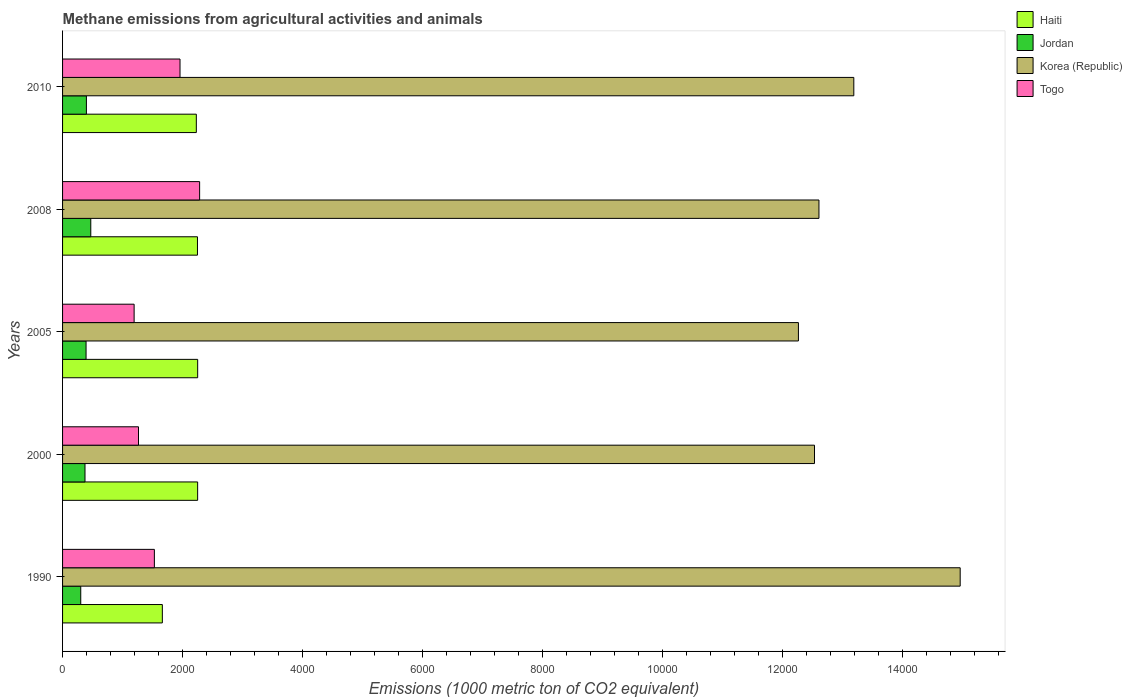How many different coloured bars are there?
Offer a very short reply. 4. Are the number of bars on each tick of the Y-axis equal?
Provide a succinct answer. Yes. How many bars are there on the 1st tick from the bottom?
Your answer should be very brief. 4. In how many cases, is the number of bars for a given year not equal to the number of legend labels?
Provide a short and direct response. 0. What is the amount of methane emitted in Jordan in 1990?
Your response must be concise. 303.3. Across all years, what is the maximum amount of methane emitted in Togo?
Your answer should be compact. 2285.6. Across all years, what is the minimum amount of methane emitted in Jordan?
Your answer should be very brief. 303.3. What is the total amount of methane emitted in Jordan in the graph?
Keep it short and to the point. 1937.1. What is the difference between the amount of methane emitted in Haiti in 1990 and that in 2008?
Your answer should be very brief. -585.6. What is the difference between the amount of methane emitted in Togo in 1990 and the amount of methane emitted in Haiti in 2005?
Offer a very short reply. -721.9. What is the average amount of methane emitted in Haiti per year?
Make the answer very short. 2129.88. In the year 1990, what is the difference between the amount of methane emitted in Togo and amount of methane emitted in Jordan?
Offer a very short reply. 1227.8. What is the ratio of the amount of methane emitted in Togo in 2000 to that in 2008?
Offer a very short reply. 0.55. Is the amount of methane emitted in Togo in 2000 less than that in 2008?
Offer a terse response. Yes. Is the difference between the amount of methane emitted in Togo in 1990 and 2000 greater than the difference between the amount of methane emitted in Jordan in 1990 and 2000?
Your answer should be compact. Yes. What is the difference between the highest and the second highest amount of methane emitted in Korea (Republic)?
Ensure brevity in your answer.  1774. What is the difference between the highest and the lowest amount of methane emitted in Korea (Republic)?
Provide a short and direct response. 2697.7. Is it the case that in every year, the sum of the amount of methane emitted in Korea (Republic) and amount of methane emitted in Haiti is greater than the sum of amount of methane emitted in Togo and amount of methane emitted in Jordan?
Offer a terse response. Yes. What does the 3rd bar from the top in 2010 represents?
Your answer should be compact. Jordan. What does the 3rd bar from the bottom in 2008 represents?
Give a very brief answer. Korea (Republic). Is it the case that in every year, the sum of the amount of methane emitted in Korea (Republic) and amount of methane emitted in Togo is greater than the amount of methane emitted in Jordan?
Give a very brief answer. Yes. How many bars are there?
Give a very brief answer. 20. What is the difference between two consecutive major ticks on the X-axis?
Keep it short and to the point. 2000. Are the values on the major ticks of X-axis written in scientific E-notation?
Ensure brevity in your answer.  No. Does the graph contain grids?
Offer a terse response. No. Where does the legend appear in the graph?
Provide a short and direct response. Top right. How many legend labels are there?
Offer a very short reply. 4. How are the legend labels stacked?
Offer a very short reply. Vertical. What is the title of the graph?
Your answer should be very brief. Methane emissions from agricultural activities and animals. What is the label or title of the X-axis?
Offer a very short reply. Emissions (1000 metric ton of CO2 equivalent). What is the Emissions (1000 metric ton of CO2 equivalent) in Haiti in 1990?
Keep it short and to the point. 1663.9. What is the Emissions (1000 metric ton of CO2 equivalent) in Jordan in 1990?
Provide a short and direct response. 303.3. What is the Emissions (1000 metric ton of CO2 equivalent) in Korea (Republic) in 1990?
Ensure brevity in your answer.  1.50e+04. What is the Emissions (1000 metric ton of CO2 equivalent) of Togo in 1990?
Your answer should be very brief. 1531.1. What is the Emissions (1000 metric ton of CO2 equivalent) of Haiti in 2000?
Offer a very short reply. 2252.5. What is the Emissions (1000 metric ton of CO2 equivalent) of Jordan in 2000?
Provide a short and direct response. 374. What is the Emissions (1000 metric ton of CO2 equivalent) in Korea (Republic) in 2000?
Keep it short and to the point. 1.25e+04. What is the Emissions (1000 metric ton of CO2 equivalent) in Togo in 2000?
Keep it short and to the point. 1266.2. What is the Emissions (1000 metric ton of CO2 equivalent) of Haiti in 2005?
Keep it short and to the point. 2253. What is the Emissions (1000 metric ton of CO2 equivalent) in Jordan in 2005?
Give a very brief answer. 391.8. What is the Emissions (1000 metric ton of CO2 equivalent) of Korea (Republic) in 2005?
Keep it short and to the point. 1.23e+04. What is the Emissions (1000 metric ton of CO2 equivalent) in Togo in 2005?
Give a very brief answer. 1193.3. What is the Emissions (1000 metric ton of CO2 equivalent) of Haiti in 2008?
Your response must be concise. 2249.5. What is the Emissions (1000 metric ton of CO2 equivalent) in Jordan in 2008?
Offer a terse response. 470.4. What is the Emissions (1000 metric ton of CO2 equivalent) in Korea (Republic) in 2008?
Keep it short and to the point. 1.26e+04. What is the Emissions (1000 metric ton of CO2 equivalent) of Togo in 2008?
Offer a terse response. 2285.6. What is the Emissions (1000 metric ton of CO2 equivalent) of Haiti in 2010?
Your answer should be very brief. 2230.5. What is the Emissions (1000 metric ton of CO2 equivalent) of Jordan in 2010?
Ensure brevity in your answer.  397.6. What is the Emissions (1000 metric ton of CO2 equivalent) of Korea (Republic) in 2010?
Your response must be concise. 1.32e+04. What is the Emissions (1000 metric ton of CO2 equivalent) in Togo in 2010?
Ensure brevity in your answer.  1958.5. Across all years, what is the maximum Emissions (1000 metric ton of CO2 equivalent) of Haiti?
Your answer should be very brief. 2253. Across all years, what is the maximum Emissions (1000 metric ton of CO2 equivalent) in Jordan?
Provide a succinct answer. 470.4. Across all years, what is the maximum Emissions (1000 metric ton of CO2 equivalent) in Korea (Republic)?
Offer a very short reply. 1.50e+04. Across all years, what is the maximum Emissions (1000 metric ton of CO2 equivalent) of Togo?
Give a very brief answer. 2285.6. Across all years, what is the minimum Emissions (1000 metric ton of CO2 equivalent) in Haiti?
Your answer should be very brief. 1663.9. Across all years, what is the minimum Emissions (1000 metric ton of CO2 equivalent) of Jordan?
Your answer should be very brief. 303.3. Across all years, what is the minimum Emissions (1000 metric ton of CO2 equivalent) in Korea (Republic)?
Make the answer very short. 1.23e+04. Across all years, what is the minimum Emissions (1000 metric ton of CO2 equivalent) in Togo?
Offer a terse response. 1193.3. What is the total Emissions (1000 metric ton of CO2 equivalent) of Haiti in the graph?
Offer a very short reply. 1.06e+04. What is the total Emissions (1000 metric ton of CO2 equivalent) of Jordan in the graph?
Your answer should be very brief. 1937.1. What is the total Emissions (1000 metric ton of CO2 equivalent) of Korea (Republic) in the graph?
Offer a very short reply. 6.56e+04. What is the total Emissions (1000 metric ton of CO2 equivalent) in Togo in the graph?
Your answer should be compact. 8234.7. What is the difference between the Emissions (1000 metric ton of CO2 equivalent) in Haiti in 1990 and that in 2000?
Keep it short and to the point. -588.6. What is the difference between the Emissions (1000 metric ton of CO2 equivalent) of Jordan in 1990 and that in 2000?
Your answer should be very brief. -70.7. What is the difference between the Emissions (1000 metric ton of CO2 equivalent) in Korea (Republic) in 1990 and that in 2000?
Keep it short and to the point. 2429.6. What is the difference between the Emissions (1000 metric ton of CO2 equivalent) of Togo in 1990 and that in 2000?
Offer a terse response. 264.9. What is the difference between the Emissions (1000 metric ton of CO2 equivalent) of Haiti in 1990 and that in 2005?
Provide a succinct answer. -589.1. What is the difference between the Emissions (1000 metric ton of CO2 equivalent) of Jordan in 1990 and that in 2005?
Ensure brevity in your answer.  -88.5. What is the difference between the Emissions (1000 metric ton of CO2 equivalent) in Korea (Republic) in 1990 and that in 2005?
Keep it short and to the point. 2697.7. What is the difference between the Emissions (1000 metric ton of CO2 equivalent) in Togo in 1990 and that in 2005?
Make the answer very short. 337.8. What is the difference between the Emissions (1000 metric ton of CO2 equivalent) in Haiti in 1990 and that in 2008?
Your answer should be compact. -585.6. What is the difference between the Emissions (1000 metric ton of CO2 equivalent) of Jordan in 1990 and that in 2008?
Your response must be concise. -167.1. What is the difference between the Emissions (1000 metric ton of CO2 equivalent) in Korea (Republic) in 1990 and that in 2008?
Make the answer very short. 2355.3. What is the difference between the Emissions (1000 metric ton of CO2 equivalent) of Togo in 1990 and that in 2008?
Provide a short and direct response. -754.5. What is the difference between the Emissions (1000 metric ton of CO2 equivalent) of Haiti in 1990 and that in 2010?
Offer a terse response. -566.6. What is the difference between the Emissions (1000 metric ton of CO2 equivalent) in Jordan in 1990 and that in 2010?
Make the answer very short. -94.3. What is the difference between the Emissions (1000 metric ton of CO2 equivalent) in Korea (Republic) in 1990 and that in 2010?
Your answer should be very brief. 1774. What is the difference between the Emissions (1000 metric ton of CO2 equivalent) in Togo in 1990 and that in 2010?
Your answer should be very brief. -427.4. What is the difference between the Emissions (1000 metric ton of CO2 equivalent) in Jordan in 2000 and that in 2005?
Your response must be concise. -17.8. What is the difference between the Emissions (1000 metric ton of CO2 equivalent) of Korea (Republic) in 2000 and that in 2005?
Your answer should be compact. 268.1. What is the difference between the Emissions (1000 metric ton of CO2 equivalent) in Togo in 2000 and that in 2005?
Keep it short and to the point. 72.9. What is the difference between the Emissions (1000 metric ton of CO2 equivalent) in Haiti in 2000 and that in 2008?
Keep it short and to the point. 3. What is the difference between the Emissions (1000 metric ton of CO2 equivalent) in Jordan in 2000 and that in 2008?
Offer a terse response. -96.4. What is the difference between the Emissions (1000 metric ton of CO2 equivalent) of Korea (Republic) in 2000 and that in 2008?
Offer a very short reply. -74.3. What is the difference between the Emissions (1000 metric ton of CO2 equivalent) in Togo in 2000 and that in 2008?
Give a very brief answer. -1019.4. What is the difference between the Emissions (1000 metric ton of CO2 equivalent) of Haiti in 2000 and that in 2010?
Your answer should be compact. 22. What is the difference between the Emissions (1000 metric ton of CO2 equivalent) in Jordan in 2000 and that in 2010?
Your answer should be compact. -23.6. What is the difference between the Emissions (1000 metric ton of CO2 equivalent) in Korea (Republic) in 2000 and that in 2010?
Offer a very short reply. -655.6. What is the difference between the Emissions (1000 metric ton of CO2 equivalent) of Togo in 2000 and that in 2010?
Your answer should be very brief. -692.3. What is the difference between the Emissions (1000 metric ton of CO2 equivalent) of Jordan in 2005 and that in 2008?
Keep it short and to the point. -78.6. What is the difference between the Emissions (1000 metric ton of CO2 equivalent) in Korea (Republic) in 2005 and that in 2008?
Offer a terse response. -342.4. What is the difference between the Emissions (1000 metric ton of CO2 equivalent) in Togo in 2005 and that in 2008?
Provide a short and direct response. -1092.3. What is the difference between the Emissions (1000 metric ton of CO2 equivalent) of Haiti in 2005 and that in 2010?
Your response must be concise. 22.5. What is the difference between the Emissions (1000 metric ton of CO2 equivalent) of Jordan in 2005 and that in 2010?
Your answer should be compact. -5.8. What is the difference between the Emissions (1000 metric ton of CO2 equivalent) of Korea (Republic) in 2005 and that in 2010?
Your response must be concise. -923.7. What is the difference between the Emissions (1000 metric ton of CO2 equivalent) of Togo in 2005 and that in 2010?
Offer a very short reply. -765.2. What is the difference between the Emissions (1000 metric ton of CO2 equivalent) of Jordan in 2008 and that in 2010?
Provide a succinct answer. 72.8. What is the difference between the Emissions (1000 metric ton of CO2 equivalent) in Korea (Republic) in 2008 and that in 2010?
Offer a terse response. -581.3. What is the difference between the Emissions (1000 metric ton of CO2 equivalent) in Togo in 2008 and that in 2010?
Your answer should be compact. 327.1. What is the difference between the Emissions (1000 metric ton of CO2 equivalent) in Haiti in 1990 and the Emissions (1000 metric ton of CO2 equivalent) in Jordan in 2000?
Your answer should be very brief. 1289.9. What is the difference between the Emissions (1000 metric ton of CO2 equivalent) of Haiti in 1990 and the Emissions (1000 metric ton of CO2 equivalent) of Korea (Republic) in 2000?
Offer a terse response. -1.09e+04. What is the difference between the Emissions (1000 metric ton of CO2 equivalent) in Haiti in 1990 and the Emissions (1000 metric ton of CO2 equivalent) in Togo in 2000?
Ensure brevity in your answer.  397.7. What is the difference between the Emissions (1000 metric ton of CO2 equivalent) in Jordan in 1990 and the Emissions (1000 metric ton of CO2 equivalent) in Korea (Republic) in 2000?
Your answer should be very brief. -1.22e+04. What is the difference between the Emissions (1000 metric ton of CO2 equivalent) of Jordan in 1990 and the Emissions (1000 metric ton of CO2 equivalent) of Togo in 2000?
Make the answer very short. -962.9. What is the difference between the Emissions (1000 metric ton of CO2 equivalent) in Korea (Republic) in 1990 and the Emissions (1000 metric ton of CO2 equivalent) in Togo in 2000?
Your answer should be very brief. 1.37e+04. What is the difference between the Emissions (1000 metric ton of CO2 equivalent) in Haiti in 1990 and the Emissions (1000 metric ton of CO2 equivalent) in Jordan in 2005?
Provide a short and direct response. 1272.1. What is the difference between the Emissions (1000 metric ton of CO2 equivalent) in Haiti in 1990 and the Emissions (1000 metric ton of CO2 equivalent) in Korea (Republic) in 2005?
Your response must be concise. -1.06e+04. What is the difference between the Emissions (1000 metric ton of CO2 equivalent) in Haiti in 1990 and the Emissions (1000 metric ton of CO2 equivalent) in Togo in 2005?
Provide a short and direct response. 470.6. What is the difference between the Emissions (1000 metric ton of CO2 equivalent) of Jordan in 1990 and the Emissions (1000 metric ton of CO2 equivalent) of Korea (Republic) in 2005?
Offer a terse response. -1.20e+04. What is the difference between the Emissions (1000 metric ton of CO2 equivalent) of Jordan in 1990 and the Emissions (1000 metric ton of CO2 equivalent) of Togo in 2005?
Provide a succinct answer. -890. What is the difference between the Emissions (1000 metric ton of CO2 equivalent) in Korea (Republic) in 1990 and the Emissions (1000 metric ton of CO2 equivalent) in Togo in 2005?
Your answer should be very brief. 1.38e+04. What is the difference between the Emissions (1000 metric ton of CO2 equivalent) in Haiti in 1990 and the Emissions (1000 metric ton of CO2 equivalent) in Jordan in 2008?
Your answer should be compact. 1193.5. What is the difference between the Emissions (1000 metric ton of CO2 equivalent) of Haiti in 1990 and the Emissions (1000 metric ton of CO2 equivalent) of Korea (Republic) in 2008?
Offer a very short reply. -1.09e+04. What is the difference between the Emissions (1000 metric ton of CO2 equivalent) in Haiti in 1990 and the Emissions (1000 metric ton of CO2 equivalent) in Togo in 2008?
Your answer should be very brief. -621.7. What is the difference between the Emissions (1000 metric ton of CO2 equivalent) of Jordan in 1990 and the Emissions (1000 metric ton of CO2 equivalent) of Korea (Republic) in 2008?
Provide a short and direct response. -1.23e+04. What is the difference between the Emissions (1000 metric ton of CO2 equivalent) of Jordan in 1990 and the Emissions (1000 metric ton of CO2 equivalent) of Togo in 2008?
Offer a terse response. -1982.3. What is the difference between the Emissions (1000 metric ton of CO2 equivalent) of Korea (Republic) in 1990 and the Emissions (1000 metric ton of CO2 equivalent) of Togo in 2008?
Ensure brevity in your answer.  1.27e+04. What is the difference between the Emissions (1000 metric ton of CO2 equivalent) of Haiti in 1990 and the Emissions (1000 metric ton of CO2 equivalent) of Jordan in 2010?
Offer a very short reply. 1266.3. What is the difference between the Emissions (1000 metric ton of CO2 equivalent) of Haiti in 1990 and the Emissions (1000 metric ton of CO2 equivalent) of Korea (Republic) in 2010?
Offer a terse response. -1.15e+04. What is the difference between the Emissions (1000 metric ton of CO2 equivalent) of Haiti in 1990 and the Emissions (1000 metric ton of CO2 equivalent) of Togo in 2010?
Your answer should be compact. -294.6. What is the difference between the Emissions (1000 metric ton of CO2 equivalent) in Jordan in 1990 and the Emissions (1000 metric ton of CO2 equivalent) in Korea (Republic) in 2010?
Your response must be concise. -1.29e+04. What is the difference between the Emissions (1000 metric ton of CO2 equivalent) of Jordan in 1990 and the Emissions (1000 metric ton of CO2 equivalent) of Togo in 2010?
Ensure brevity in your answer.  -1655.2. What is the difference between the Emissions (1000 metric ton of CO2 equivalent) of Korea (Republic) in 1990 and the Emissions (1000 metric ton of CO2 equivalent) of Togo in 2010?
Offer a very short reply. 1.30e+04. What is the difference between the Emissions (1000 metric ton of CO2 equivalent) of Haiti in 2000 and the Emissions (1000 metric ton of CO2 equivalent) of Jordan in 2005?
Make the answer very short. 1860.7. What is the difference between the Emissions (1000 metric ton of CO2 equivalent) of Haiti in 2000 and the Emissions (1000 metric ton of CO2 equivalent) of Korea (Republic) in 2005?
Give a very brief answer. -1.00e+04. What is the difference between the Emissions (1000 metric ton of CO2 equivalent) in Haiti in 2000 and the Emissions (1000 metric ton of CO2 equivalent) in Togo in 2005?
Provide a short and direct response. 1059.2. What is the difference between the Emissions (1000 metric ton of CO2 equivalent) of Jordan in 2000 and the Emissions (1000 metric ton of CO2 equivalent) of Korea (Republic) in 2005?
Your answer should be compact. -1.19e+04. What is the difference between the Emissions (1000 metric ton of CO2 equivalent) in Jordan in 2000 and the Emissions (1000 metric ton of CO2 equivalent) in Togo in 2005?
Provide a succinct answer. -819.3. What is the difference between the Emissions (1000 metric ton of CO2 equivalent) of Korea (Republic) in 2000 and the Emissions (1000 metric ton of CO2 equivalent) of Togo in 2005?
Your answer should be compact. 1.13e+04. What is the difference between the Emissions (1000 metric ton of CO2 equivalent) in Haiti in 2000 and the Emissions (1000 metric ton of CO2 equivalent) in Jordan in 2008?
Give a very brief answer. 1782.1. What is the difference between the Emissions (1000 metric ton of CO2 equivalent) in Haiti in 2000 and the Emissions (1000 metric ton of CO2 equivalent) in Korea (Republic) in 2008?
Give a very brief answer. -1.04e+04. What is the difference between the Emissions (1000 metric ton of CO2 equivalent) in Haiti in 2000 and the Emissions (1000 metric ton of CO2 equivalent) in Togo in 2008?
Keep it short and to the point. -33.1. What is the difference between the Emissions (1000 metric ton of CO2 equivalent) in Jordan in 2000 and the Emissions (1000 metric ton of CO2 equivalent) in Korea (Republic) in 2008?
Keep it short and to the point. -1.22e+04. What is the difference between the Emissions (1000 metric ton of CO2 equivalent) of Jordan in 2000 and the Emissions (1000 metric ton of CO2 equivalent) of Togo in 2008?
Keep it short and to the point. -1911.6. What is the difference between the Emissions (1000 metric ton of CO2 equivalent) of Korea (Republic) in 2000 and the Emissions (1000 metric ton of CO2 equivalent) of Togo in 2008?
Give a very brief answer. 1.03e+04. What is the difference between the Emissions (1000 metric ton of CO2 equivalent) in Haiti in 2000 and the Emissions (1000 metric ton of CO2 equivalent) in Jordan in 2010?
Make the answer very short. 1854.9. What is the difference between the Emissions (1000 metric ton of CO2 equivalent) of Haiti in 2000 and the Emissions (1000 metric ton of CO2 equivalent) of Korea (Republic) in 2010?
Your response must be concise. -1.09e+04. What is the difference between the Emissions (1000 metric ton of CO2 equivalent) of Haiti in 2000 and the Emissions (1000 metric ton of CO2 equivalent) of Togo in 2010?
Make the answer very short. 294. What is the difference between the Emissions (1000 metric ton of CO2 equivalent) of Jordan in 2000 and the Emissions (1000 metric ton of CO2 equivalent) of Korea (Republic) in 2010?
Make the answer very short. -1.28e+04. What is the difference between the Emissions (1000 metric ton of CO2 equivalent) of Jordan in 2000 and the Emissions (1000 metric ton of CO2 equivalent) of Togo in 2010?
Ensure brevity in your answer.  -1584.5. What is the difference between the Emissions (1000 metric ton of CO2 equivalent) in Korea (Republic) in 2000 and the Emissions (1000 metric ton of CO2 equivalent) in Togo in 2010?
Ensure brevity in your answer.  1.06e+04. What is the difference between the Emissions (1000 metric ton of CO2 equivalent) of Haiti in 2005 and the Emissions (1000 metric ton of CO2 equivalent) of Jordan in 2008?
Provide a short and direct response. 1782.6. What is the difference between the Emissions (1000 metric ton of CO2 equivalent) of Haiti in 2005 and the Emissions (1000 metric ton of CO2 equivalent) of Korea (Republic) in 2008?
Your answer should be very brief. -1.04e+04. What is the difference between the Emissions (1000 metric ton of CO2 equivalent) in Haiti in 2005 and the Emissions (1000 metric ton of CO2 equivalent) in Togo in 2008?
Offer a very short reply. -32.6. What is the difference between the Emissions (1000 metric ton of CO2 equivalent) of Jordan in 2005 and the Emissions (1000 metric ton of CO2 equivalent) of Korea (Republic) in 2008?
Provide a short and direct response. -1.22e+04. What is the difference between the Emissions (1000 metric ton of CO2 equivalent) in Jordan in 2005 and the Emissions (1000 metric ton of CO2 equivalent) in Togo in 2008?
Your answer should be compact. -1893.8. What is the difference between the Emissions (1000 metric ton of CO2 equivalent) in Korea (Republic) in 2005 and the Emissions (1000 metric ton of CO2 equivalent) in Togo in 2008?
Make the answer very short. 9985.4. What is the difference between the Emissions (1000 metric ton of CO2 equivalent) of Haiti in 2005 and the Emissions (1000 metric ton of CO2 equivalent) of Jordan in 2010?
Keep it short and to the point. 1855.4. What is the difference between the Emissions (1000 metric ton of CO2 equivalent) in Haiti in 2005 and the Emissions (1000 metric ton of CO2 equivalent) in Korea (Republic) in 2010?
Keep it short and to the point. -1.09e+04. What is the difference between the Emissions (1000 metric ton of CO2 equivalent) of Haiti in 2005 and the Emissions (1000 metric ton of CO2 equivalent) of Togo in 2010?
Make the answer very short. 294.5. What is the difference between the Emissions (1000 metric ton of CO2 equivalent) of Jordan in 2005 and the Emissions (1000 metric ton of CO2 equivalent) of Korea (Republic) in 2010?
Offer a terse response. -1.28e+04. What is the difference between the Emissions (1000 metric ton of CO2 equivalent) of Jordan in 2005 and the Emissions (1000 metric ton of CO2 equivalent) of Togo in 2010?
Make the answer very short. -1566.7. What is the difference between the Emissions (1000 metric ton of CO2 equivalent) in Korea (Republic) in 2005 and the Emissions (1000 metric ton of CO2 equivalent) in Togo in 2010?
Ensure brevity in your answer.  1.03e+04. What is the difference between the Emissions (1000 metric ton of CO2 equivalent) of Haiti in 2008 and the Emissions (1000 metric ton of CO2 equivalent) of Jordan in 2010?
Keep it short and to the point. 1851.9. What is the difference between the Emissions (1000 metric ton of CO2 equivalent) in Haiti in 2008 and the Emissions (1000 metric ton of CO2 equivalent) in Korea (Republic) in 2010?
Your response must be concise. -1.09e+04. What is the difference between the Emissions (1000 metric ton of CO2 equivalent) in Haiti in 2008 and the Emissions (1000 metric ton of CO2 equivalent) in Togo in 2010?
Offer a terse response. 291. What is the difference between the Emissions (1000 metric ton of CO2 equivalent) of Jordan in 2008 and the Emissions (1000 metric ton of CO2 equivalent) of Korea (Republic) in 2010?
Your response must be concise. -1.27e+04. What is the difference between the Emissions (1000 metric ton of CO2 equivalent) in Jordan in 2008 and the Emissions (1000 metric ton of CO2 equivalent) in Togo in 2010?
Keep it short and to the point. -1488.1. What is the difference between the Emissions (1000 metric ton of CO2 equivalent) of Korea (Republic) in 2008 and the Emissions (1000 metric ton of CO2 equivalent) of Togo in 2010?
Make the answer very short. 1.07e+04. What is the average Emissions (1000 metric ton of CO2 equivalent) of Haiti per year?
Provide a short and direct response. 2129.88. What is the average Emissions (1000 metric ton of CO2 equivalent) of Jordan per year?
Provide a succinct answer. 387.42. What is the average Emissions (1000 metric ton of CO2 equivalent) in Korea (Republic) per year?
Make the answer very short. 1.31e+04. What is the average Emissions (1000 metric ton of CO2 equivalent) in Togo per year?
Keep it short and to the point. 1646.94. In the year 1990, what is the difference between the Emissions (1000 metric ton of CO2 equivalent) in Haiti and Emissions (1000 metric ton of CO2 equivalent) in Jordan?
Keep it short and to the point. 1360.6. In the year 1990, what is the difference between the Emissions (1000 metric ton of CO2 equivalent) of Haiti and Emissions (1000 metric ton of CO2 equivalent) of Korea (Republic)?
Offer a very short reply. -1.33e+04. In the year 1990, what is the difference between the Emissions (1000 metric ton of CO2 equivalent) in Haiti and Emissions (1000 metric ton of CO2 equivalent) in Togo?
Provide a succinct answer. 132.8. In the year 1990, what is the difference between the Emissions (1000 metric ton of CO2 equivalent) in Jordan and Emissions (1000 metric ton of CO2 equivalent) in Korea (Republic)?
Offer a very short reply. -1.47e+04. In the year 1990, what is the difference between the Emissions (1000 metric ton of CO2 equivalent) in Jordan and Emissions (1000 metric ton of CO2 equivalent) in Togo?
Provide a succinct answer. -1227.8. In the year 1990, what is the difference between the Emissions (1000 metric ton of CO2 equivalent) of Korea (Republic) and Emissions (1000 metric ton of CO2 equivalent) of Togo?
Provide a short and direct response. 1.34e+04. In the year 2000, what is the difference between the Emissions (1000 metric ton of CO2 equivalent) in Haiti and Emissions (1000 metric ton of CO2 equivalent) in Jordan?
Ensure brevity in your answer.  1878.5. In the year 2000, what is the difference between the Emissions (1000 metric ton of CO2 equivalent) in Haiti and Emissions (1000 metric ton of CO2 equivalent) in Korea (Republic)?
Give a very brief answer. -1.03e+04. In the year 2000, what is the difference between the Emissions (1000 metric ton of CO2 equivalent) of Haiti and Emissions (1000 metric ton of CO2 equivalent) of Togo?
Ensure brevity in your answer.  986.3. In the year 2000, what is the difference between the Emissions (1000 metric ton of CO2 equivalent) in Jordan and Emissions (1000 metric ton of CO2 equivalent) in Korea (Republic)?
Your answer should be very brief. -1.22e+04. In the year 2000, what is the difference between the Emissions (1000 metric ton of CO2 equivalent) in Jordan and Emissions (1000 metric ton of CO2 equivalent) in Togo?
Your answer should be compact. -892.2. In the year 2000, what is the difference between the Emissions (1000 metric ton of CO2 equivalent) in Korea (Republic) and Emissions (1000 metric ton of CO2 equivalent) in Togo?
Offer a very short reply. 1.13e+04. In the year 2005, what is the difference between the Emissions (1000 metric ton of CO2 equivalent) of Haiti and Emissions (1000 metric ton of CO2 equivalent) of Jordan?
Your response must be concise. 1861.2. In the year 2005, what is the difference between the Emissions (1000 metric ton of CO2 equivalent) of Haiti and Emissions (1000 metric ton of CO2 equivalent) of Korea (Republic)?
Give a very brief answer. -1.00e+04. In the year 2005, what is the difference between the Emissions (1000 metric ton of CO2 equivalent) in Haiti and Emissions (1000 metric ton of CO2 equivalent) in Togo?
Keep it short and to the point. 1059.7. In the year 2005, what is the difference between the Emissions (1000 metric ton of CO2 equivalent) of Jordan and Emissions (1000 metric ton of CO2 equivalent) of Korea (Republic)?
Offer a very short reply. -1.19e+04. In the year 2005, what is the difference between the Emissions (1000 metric ton of CO2 equivalent) in Jordan and Emissions (1000 metric ton of CO2 equivalent) in Togo?
Provide a succinct answer. -801.5. In the year 2005, what is the difference between the Emissions (1000 metric ton of CO2 equivalent) in Korea (Republic) and Emissions (1000 metric ton of CO2 equivalent) in Togo?
Give a very brief answer. 1.11e+04. In the year 2008, what is the difference between the Emissions (1000 metric ton of CO2 equivalent) of Haiti and Emissions (1000 metric ton of CO2 equivalent) of Jordan?
Your answer should be very brief. 1779.1. In the year 2008, what is the difference between the Emissions (1000 metric ton of CO2 equivalent) of Haiti and Emissions (1000 metric ton of CO2 equivalent) of Korea (Republic)?
Ensure brevity in your answer.  -1.04e+04. In the year 2008, what is the difference between the Emissions (1000 metric ton of CO2 equivalent) of Haiti and Emissions (1000 metric ton of CO2 equivalent) of Togo?
Make the answer very short. -36.1. In the year 2008, what is the difference between the Emissions (1000 metric ton of CO2 equivalent) of Jordan and Emissions (1000 metric ton of CO2 equivalent) of Korea (Republic)?
Keep it short and to the point. -1.21e+04. In the year 2008, what is the difference between the Emissions (1000 metric ton of CO2 equivalent) in Jordan and Emissions (1000 metric ton of CO2 equivalent) in Togo?
Your answer should be very brief. -1815.2. In the year 2008, what is the difference between the Emissions (1000 metric ton of CO2 equivalent) in Korea (Republic) and Emissions (1000 metric ton of CO2 equivalent) in Togo?
Offer a very short reply. 1.03e+04. In the year 2010, what is the difference between the Emissions (1000 metric ton of CO2 equivalent) in Haiti and Emissions (1000 metric ton of CO2 equivalent) in Jordan?
Provide a succinct answer. 1832.9. In the year 2010, what is the difference between the Emissions (1000 metric ton of CO2 equivalent) of Haiti and Emissions (1000 metric ton of CO2 equivalent) of Korea (Republic)?
Your answer should be compact. -1.10e+04. In the year 2010, what is the difference between the Emissions (1000 metric ton of CO2 equivalent) of Haiti and Emissions (1000 metric ton of CO2 equivalent) of Togo?
Make the answer very short. 272. In the year 2010, what is the difference between the Emissions (1000 metric ton of CO2 equivalent) of Jordan and Emissions (1000 metric ton of CO2 equivalent) of Korea (Republic)?
Your answer should be compact. -1.28e+04. In the year 2010, what is the difference between the Emissions (1000 metric ton of CO2 equivalent) of Jordan and Emissions (1000 metric ton of CO2 equivalent) of Togo?
Your answer should be very brief. -1560.9. In the year 2010, what is the difference between the Emissions (1000 metric ton of CO2 equivalent) of Korea (Republic) and Emissions (1000 metric ton of CO2 equivalent) of Togo?
Give a very brief answer. 1.12e+04. What is the ratio of the Emissions (1000 metric ton of CO2 equivalent) of Haiti in 1990 to that in 2000?
Offer a very short reply. 0.74. What is the ratio of the Emissions (1000 metric ton of CO2 equivalent) in Jordan in 1990 to that in 2000?
Provide a short and direct response. 0.81. What is the ratio of the Emissions (1000 metric ton of CO2 equivalent) of Korea (Republic) in 1990 to that in 2000?
Offer a terse response. 1.19. What is the ratio of the Emissions (1000 metric ton of CO2 equivalent) of Togo in 1990 to that in 2000?
Make the answer very short. 1.21. What is the ratio of the Emissions (1000 metric ton of CO2 equivalent) in Haiti in 1990 to that in 2005?
Provide a short and direct response. 0.74. What is the ratio of the Emissions (1000 metric ton of CO2 equivalent) in Jordan in 1990 to that in 2005?
Provide a short and direct response. 0.77. What is the ratio of the Emissions (1000 metric ton of CO2 equivalent) in Korea (Republic) in 1990 to that in 2005?
Provide a succinct answer. 1.22. What is the ratio of the Emissions (1000 metric ton of CO2 equivalent) of Togo in 1990 to that in 2005?
Ensure brevity in your answer.  1.28. What is the ratio of the Emissions (1000 metric ton of CO2 equivalent) of Haiti in 1990 to that in 2008?
Your answer should be compact. 0.74. What is the ratio of the Emissions (1000 metric ton of CO2 equivalent) of Jordan in 1990 to that in 2008?
Offer a very short reply. 0.64. What is the ratio of the Emissions (1000 metric ton of CO2 equivalent) of Korea (Republic) in 1990 to that in 2008?
Ensure brevity in your answer.  1.19. What is the ratio of the Emissions (1000 metric ton of CO2 equivalent) in Togo in 1990 to that in 2008?
Ensure brevity in your answer.  0.67. What is the ratio of the Emissions (1000 metric ton of CO2 equivalent) of Haiti in 1990 to that in 2010?
Offer a terse response. 0.75. What is the ratio of the Emissions (1000 metric ton of CO2 equivalent) of Jordan in 1990 to that in 2010?
Offer a very short reply. 0.76. What is the ratio of the Emissions (1000 metric ton of CO2 equivalent) of Korea (Republic) in 1990 to that in 2010?
Ensure brevity in your answer.  1.13. What is the ratio of the Emissions (1000 metric ton of CO2 equivalent) in Togo in 1990 to that in 2010?
Ensure brevity in your answer.  0.78. What is the ratio of the Emissions (1000 metric ton of CO2 equivalent) in Jordan in 2000 to that in 2005?
Keep it short and to the point. 0.95. What is the ratio of the Emissions (1000 metric ton of CO2 equivalent) in Korea (Republic) in 2000 to that in 2005?
Make the answer very short. 1.02. What is the ratio of the Emissions (1000 metric ton of CO2 equivalent) of Togo in 2000 to that in 2005?
Give a very brief answer. 1.06. What is the ratio of the Emissions (1000 metric ton of CO2 equivalent) of Jordan in 2000 to that in 2008?
Your answer should be compact. 0.8. What is the ratio of the Emissions (1000 metric ton of CO2 equivalent) in Togo in 2000 to that in 2008?
Make the answer very short. 0.55. What is the ratio of the Emissions (1000 metric ton of CO2 equivalent) in Haiti in 2000 to that in 2010?
Provide a short and direct response. 1.01. What is the ratio of the Emissions (1000 metric ton of CO2 equivalent) in Jordan in 2000 to that in 2010?
Provide a short and direct response. 0.94. What is the ratio of the Emissions (1000 metric ton of CO2 equivalent) in Korea (Republic) in 2000 to that in 2010?
Ensure brevity in your answer.  0.95. What is the ratio of the Emissions (1000 metric ton of CO2 equivalent) in Togo in 2000 to that in 2010?
Make the answer very short. 0.65. What is the ratio of the Emissions (1000 metric ton of CO2 equivalent) of Jordan in 2005 to that in 2008?
Your response must be concise. 0.83. What is the ratio of the Emissions (1000 metric ton of CO2 equivalent) of Korea (Republic) in 2005 to that in 2008?
Provide a succinct answer. 0.97. What is the ratio of the Emissions (1000 metric ton of CO2 equivalent) in Togo in 2005 to that in 2008?
Make the answer very short. 0.52. What is the ratio of the Emissions (1000 metric ton of CO2 equivalent) in Haiti in 2005 to that in 2010?
Provide a short and direct response. 1.01. What is the ratio of the Emissions (1000 metric ton of CO2 equivalent) of Jordan in 2005 to that in 2010?
Your answer should be compact. 0.99. What is the ratio of the Emissions (1000 metric ton of CO2 equivalent) in Korea (Republic) in 2005 to that in 2010?
Ensure brevity in your answer.  0.93. What is the ratio of the Emissions (1000 metric ton of CO2 equivalent) of Togo in 2005 to that in 2010?
Offer a terse response. 0.61. What is the ratio of the Emissions (1000 metric ton of CO2 equivalent) of Haiti in 2008 to that in 2010?
Your answer should be very brief. 1.01. What is the ratio of the Emissions (1000 metric ton of CO2 equivalent) in Jordan in 2008 to that in 2010?
Ensure brevity in your answer.  1.18. What is the ratio of the Emissions (1000 metric ton of CO2 equivalent) of Korea (Republic) in 2008 to that in 2010?
Give a very brief answer. 0.96. What is the ratio of the Emissions (1000 metric ton of CO2 equivalent) in Togo in 2008 to that in 2010?
Provide a succinct answer. 1.17. What is the difference between the highest and the second highest Emissions (1000 metric ton of CO2 equivalent) of Jordan?
Your response must be concise. 72.8. What is the difference between the highest and the second highest Emissions (1000 metric ton of CO2 equivalent) in Korea (Republic)?
Your answer should be very brief. 1774. What is the difference between the highest and the second highest Emissions (1000 metric ton of CO2 equivalent) of Togo?
Offer a very short reply. 327.1. What is the difference between the highest and the lowest Emissions (1000 metric ton of CO2 equivalent) in Haiti?
Ensure brevity in your answer.  589.1. What is the difference between the highest and the lowest Emissions (1000 metric ton of CO2 equivalent) of Jordan?
Your answer should be very brief. 167.1. What is the difference between the highest and the lowest Emissions (1000 metric ton of CO2 equivalent) of Korea (Republic)?
Your answer should be very brief. 2697.7. What is the difference between the highest and the lowest Emissions (1000 metric ton of CO2 equivalent) of Togo?
Your response must be concise. 1092.3. 